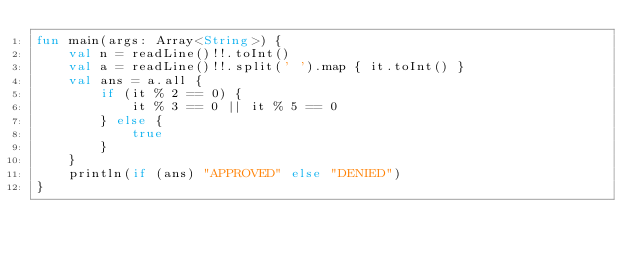Convert code to text. <code><loc_0><loc_0><loc_500><loc_500><_Kotlin_>fun main(args: Array<String>) {
    val n = readLine()!!.toInt()
    val a = readLine()!!.split(' ').map { it.toInt() }
    val ans = a.all {
        if (it % 2 == 0) {
            it % 3 == 0 || it % 5 == 0
        } else {
            true
        }
    }
    println(if (ans) "APPROVED" else "DENIED")
}
</code> 